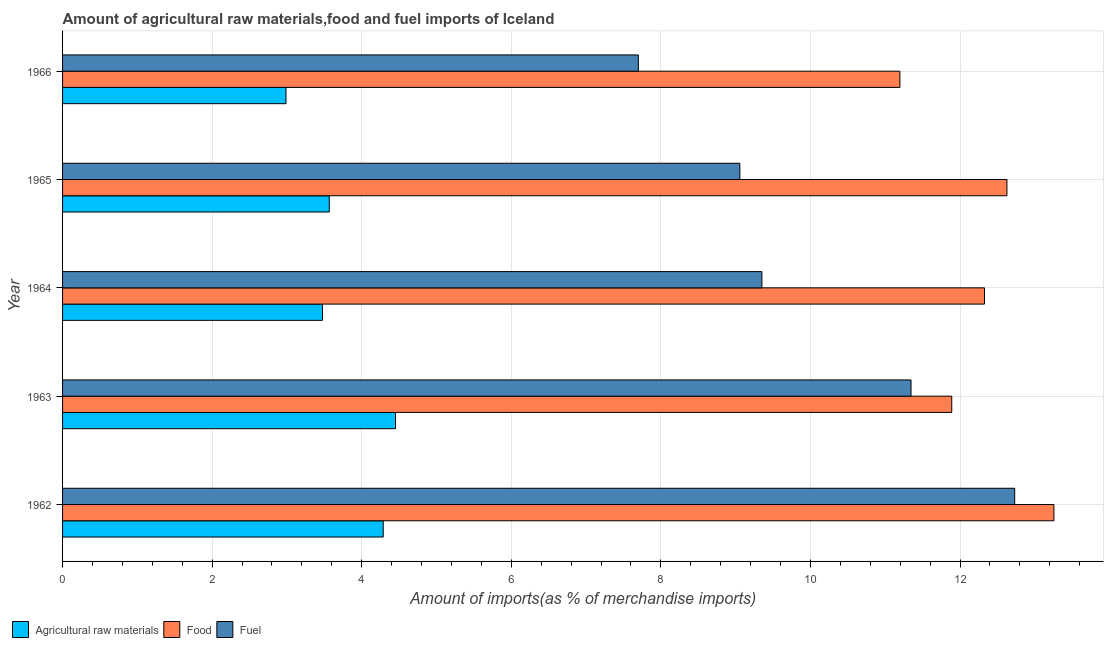How many different coloured bars are there?
Keep it short and to the point. 3. How many groups of bars are there?
Ensure brevity in your answer.  5. Are the number of bars per tick equal to the number of legend labels?
Ensure brevity in your answer.  Yes. Are the number of bars on each tick of the Y-axis equal?
Provide a short and direct response. Yes. How many bars are there on the 5th tick from the top?
Offer a terse response. 3. How many bars are there on the 3rd tick from the bottom?
Offer a terse response. 3. What is the label of the 1st group of bars from the top?
Offer a very short reply. 1966. What is the percentage of raw materials imports in 1962?
Keep it short and to the point. 4.29. Across all years, what is the maximum percentage of raw materials imports?
Your answer should be compact. 4.45. Across all years, what is the minimum percentage of food imports?
Your answer should be very brief. 11.2. In which year was the percentage of fuel imports maximum?
Provide a short and direct response. 1962. In which year was the percentage of fuel imports minimum?
Give a very brief answer. 1966. What is the total percentage of food imports in the graph?
Provide a short and direct response. 61.3. What is the difference between the percentage of food imports in 1963 and that in 1965?
Provide a short and direct response. -0.74. What is the difference between the percentage of food imports in 1964 and the percentage of fuel imports in 1962?
Provide a succinct answer. -0.4. What is the average percentage of raw materials imports per year?
Your answer should be compact. 3.75. In the year 1964, what is the difference between the percentage of food imports and percentage of raw materials imports?
Provide a short and direct response. 8.85. In how many years, is the percentage of raw materials imports greater than 12.8 %?
Provide a succinct answer. 0. What is the ratio of the percentage of raw materials imports in 1965 to that in 1966?
Your answer should be very brief. 1.19. Is the percentage of raw materials imports in 1962 less than that in 1964?
Make the answer very short. No. Is the difference between the percentage of fuel imports in 1962 and 1964 greater than the difference between the percentage of food imports in 1962 and 1964?
Make the answer very short. Yes. What is the difference between the highest and the second highest percentage of raw materials imports?
Offer a very short reply. 0.16. What is the difference between the highest and the lowest percentage of fuel imports?
Ensure brevity in your answer.  5.03. What does the 2nd bar from the top in 1964 represents?
Give a very brief answer. Food. What does the 2nd bar from the bottom in 1962 represents?
Offer a very short reply. Food. Is it the case that in every year, the sum of the percentage of raw materials imports and percentage of food imports is greater than the percentage of fuel imports?
Give a very brief answer. Yes. How many years are there in the graph?
Your answer should be very brief. 5. Does the graph contain any zero values?
Keep it short and to the point. No. Where does the legend appear in the graph?
Make the answer very short. Bottom left. How many legend labels are there?
Your response must be concise. 3. How are the legend labels stacked?
Your answer should be compact. Horizontal. What is the title of the graph?
Offer a terse response. Amount of agricultural raw materials,food and fuel imports of Iceland. What is the label or title of the X-axis?
Keep it short and to the point. Amount of imports(as % of merchandise imports). What is the Amount of imports(as % of merchandise imports) in Agricultural raw materials in 1962?
Offer a terse response. 4.29. What is the Amount of imports(as % of merchandise imports) in Food in 1962?
Ensure brevity in your answer.  13.26. What is the Amount of imports(as % of merchandise imports) in Fuel in 1962?
Your answer should be very brief. 12.73. What is the Amount of imports(as % of merchandise imports) in Agricultural raw materials in 1963?
Your response must be concise. 4.45. What is the Amount of imports(as % of merchandise imports) in Food in 1963?
Keep it short and to the point. 11.89. What is the Amount of imports(as % of merchandise imports) of Fuel in 1963?
Keep it short and to the point. 11.35. What is the Amount of imports(as % of merchandise imports) of Agricultural raw materials in 1964?
Your response must be concise. 3.48. What is the Amount of imports(as % of merchandise imports) of Food in 1964?
Your answer should be very brief. 12.33. What is the Amount of imports(as % of merchandise imports) in Fuel in 1964?
Offer a very short reply. 9.35. What is the Amount of imports(as % of merchandise imports) in Agricultural raw materials in 1965?
Make the answer very short. 3.57. What is the Amount of imports(as % of merchandise imports) of Food in 1965?
Your answer should be very brief. 12.63. What is the Amount of imports(as % of merchandise imports) of Fuel in 1965?
Your answer should be compact. 9.06. What is the Amount of imports(as % of merchandise imports) of Agricultural raw materials in 1966?
Make the answer very short. 2.99. What is the Amount of imports(as % of merchandise imports) of Food in 1966?
Provide a succinct answer. 11.2. What is the Amount of imports(as % of merchandise imports) in Fuel in 1966?
Give a very brief answer. 7.7. Across all years, what is the maximum Amount of imports(as % of merchandise imports) of Agricultural raw materials?
Make the answer very short. 4.45. Across all years, what is the maximum Amount of imports(as % of merchandise imports) in Food?
Provide a short and direct response. 13.26. Across all years, what is the maximum Amount of imports(as % of merchandise imports) in Fuel?
Keep it short and to the point. 12.73. Across all years, what is the minimum Amount of imports(as % of merchandise imports) in Agricultural raw materials?
Your answer should be compact. 2.99. Across all years, what is the minimum Amount of imports(as % of merchandise imports) of Food?
Give a very brief answer. 11.2. Across all years, what is the minimum Amount of imports(as % of merchandise imports) of Fuel?
Keep it short and to the point. 7.7. What is the total Amount of imports(as % of merchandise imports) in Agricultural raw materials in the graph?
Make the answer very short. 18.77. What is the total Amount of imports(as % of merchandise imports) in Food in the graph?
Your answer should be very brief. 61.3. What is the total Amount of imports(as % of merchandise imports) in Fuel in the graph?
Ensure brevity in your answer.  50.18. What is the difference between the Amount of imports(as % of merchandise imports) of Agricultural raw materials in 1962 and that in 1963?
Offer a terse response. -0.16. What is the difference between the Amount of imports(as % of merchandise imports) in Food in 1962 and that in 1963?
Your answer should be compact. 1.37. What is the difference between the Amount of imports(as % of merchandise imports) in Fuel in 1962 and that in 1963?
Make the answer very short. 1.39. What is the difference between the Amount of imports(as % of merchandise imports) in Agricultural raw materials in 1962 and that in 1964?
Keep it short and to the point. 0.81. What is the difference between the Amount of imports(as % of merchandise imports) in Food in 1962 and that in 1964?
Provide a short and direct response. 0.93. What is the difference between the Amount of imports(as % of merchandise imports) of Fuel in 1962 and that in 1964?
Offer a very short reply. 3.38. What is the difference between the Amount of imports(as % of merchandise imports) in Agricultural raw materials in 1962 and that in 1965?
Offer a very short reply. 0.72. What is the difference between the Amount of imports(as % of merchandise imports) of Food in 1962 and that in 1965?
Ensure brevity in your answer.  0.63. What is the difference between the Amount of imports(as % of merchandise imports) of Fuel in 1962 and that in 1965?
Give a very brief answer. 3.67. What is the difference between the Amount of imports(as % of merchandise imports) of Agricultural raw materials in 1962 and that in 1966?
Offer a terse response. 1.3. What is the difference between the Amount of imports(as % of merchandise imports) in Food in 1962 and that in 1966?
Your answer should be compact. 2.06. What is the difference between the Amount of imports(as % of merchandise imports) in Fuel in 1962 and that in 1966?
Make the answer very short. 5.03. What is the difference between the Amount of imports(as % of merchandise imports) in Agricultural raw materials in 1963 and that in 1964?
Offer a terse response. 0.98. What is the difference between the Amount of imports(as % of merchandise imports) of Food in 1963 and that in 1964?
Offer a terse response. -0.44. What is the difference between the Amount of imports(as % of merchandise imports) in Fuel in 1963 and that in 1964?
Your answer should be very brief. 1.99. What is the difference between the Amount of imports(as % of merchandise imports) of Agricultural raw materials in 1963 and that in 1965?
Offer a terse response. 0.89. What is the difference between the Amount of imports(as % of merchandise imports) in Food in 1963 and that in 1965?
Give a very brief answer. -0.74. What is the difference between the Amount of imports(as % of merchandise imports) of Fuel in 1963 and that in 1965?
Your answer should be compact. 2.29. What is the difference between the Amount of imports(as % of merchandise imports) of Agricultural raw materials in 1963 and that in 1966?
Offer a very short reply. 1.46. What is the difference between the Amount of imports(as % of merchandise imports) in Food in 1963 and that in 1966?
Provide a succinct answer. 0.69. What is the difference between the Amount of imports(as % of merchandise imports) in Fuel in 1963 and that in 1966?
Provide a short and direct response. 3.65. What is the difference between the Amount of imports(as % of merchandise imports) in Agricultural raw materials in 1964 and that in 1965?
Make the answer very short. -0.09. What is the difference between the Amount of imports(as % of merchandise imports) of Food in 1964 and that in 1965?
Your answer should be very brief. -0.3. What is the difference between the Amount of imports(as % of merchandise imports) of Fuel in 1964 and that in 1965?
Your answer should be compact. 0.29. What is the difference between the Amount of imports(as % of merchandise imports) in Agricultural raw materials in 1964 and that in 1966?
Give a very brief answer. 0.49. What is the difference between the Amount of imports(as % of merchandise imports) in Food in 1964 and that in 1966?
Keep it short and to the point. 1.13. What is the difference between the Amount of imports(as % of merchandise imports) of Fuel in 1964 and that in 1966?
Your response must be concise. 1.65. What is the difference between the Amount of imports(as % of merchandise imports) of Agricultural raw materials in 1965 and that in 1966?
Your answer should be compact. 0.58. What is the difference between the Amount of imports(as % of merchandise imports) of Food in 1965 and that in 1966?
Make the answer very short. 1.43. What is the difference between the Amount of imports(as % of merchandise imports) in Fuel in 1965 and that in 1966?
Ensure brevity in your answer.  1.36. What is the difference between the Amount of imports(as % of merchandise imports) of Agricultural raw materials in 1962 and the Amount of imports(as % of merchandise imports) of Food in 1963?
Make the answer very short. -7.6. What is the difference between the Amount of imports(as % of merchandise imports) in Agricultural raw materials in 1962 and the Amount of imports(as % of merchandise imports) in Fuel in 1963?
Provide a succinct answer. -7.06. What is the difference between the Amount of imports(as % of merchandise imports) in Food in 1962 and the Amount of imports(as % of merchandise imports) in Fuel in 1963?
Ensure brevity in your answer.  1.91. What is the difference between the Amount of imports(as % of merchandise imports) of Agricultural raw materials in 1962 and the Amount of imports(as % of merchandise imports) of Food in 1964?
Offer a very short reply. -8.04. What is the difference between the Amount of imports(as % of merchandise imports) of Agricultural raw materials in 1962 and the Amount of imports(as % of merchandise imports) of Fuel in 1964?
Give a very brief answer. -5.06. What is the difference between the Amount of imports(as % of merchandise imports) of Food in 1962 and the Amount of imports(as % of merchandise imports) of Fuel in 1964?
Offer a very short reply. 3.9. What is the difference between the Amount of imports(as % of merchandise imports) of Agricultural raw materials in 1962 and the Amount of imports(as % of merchandise imports) of Food in 1965?
Your answer should be very brief. -8.34. What is the difference between the Amount of imports(as % of merchandise imports) in Agricultural raw materials in 1962 and the Amount of imports(as % of merchandise imports) in Fuel in 1965?
Your response must be concise. -4.77. What is the difference between the Amount of imports(as % of merchandise imports) of Food in 1962 and the Amount of imports(as % of merchandise imports) of Fuel in 1965?
Provide a succinct answer. 4.2. What is the difference between the Amount of imports(as % of merchandise imports) of Agricultural raw materials in 1962 and the Amount of imports(as % of merchandise imports) of Food in 1966?
Keep it short and to the point. -6.91. What is the difference between the Amount of imports(as % of merchandise imports) of Agricultural raw materials in 1962 and the Amount of imports(as % of merchandise imports) of Fuel in 1966?
Make the answer very short. -3.41. What is the difference between the Amount of imports(as % of merchandise imports) in Food in 1962 and the Amount of imports(as % of merchandise imports) in Fuel in 1966?
Offer a very short reply. 5.56. What is the difference between the Amount of imports(as % of merchandise imports) of Agricultural raw materials in 1963 and the Amount of imports(as % of merchandise imports) of Food in 1964?
Give a very brief answer. -7.88. What is the difference between the Amount of imports(as % of merchandise imports) of Agricultural raw materials in 1963 and the Amount of imports(as % of merchandise imports) of Fuel in 1964?
Your answer should be very brief. -4.9. What is the difference between the Amount of imports(as % of merchandise imports) of Food in 1963 and the Amount of imports(as % of merchandise imports) of Fuel in 1964?
Your answer should be very brief. 2.54. What is the difference between the Amount of imports(as % of merchandise imports) in Agricultural raw materials in 1963 and the Amount of imports(as % of merchandise imports) in Food in 1965?
Give a very brief answer. -8.18. What is the difference between the Amount of imports(as % of merchandise imports) of Agricultural raw materials in 1963 and the Amount of imports(as % of merchandise imports) of Fuel in 1965?
Your response must be concise. -4.6. What is the difference between the Amount of imports(as % of merchandise imports) in Food in 1963 and the Amount of imports(as % of merchandise imports) in Fuel in 1965?
Provide a short and direct response. 2.83. What is the difference between the Amount of imports(as % of merchandise imports) of Agricultural raw materials in 1963 and the Amount of imports(as % of merchandise imports) of Food in 1966?
Provide a short and direct response. -6.74. What is the difference between the Amount of imports(as % of merchandise imports) in Agricultural raw materials in 1963 and the Amount of imports(as % of merchandise imports) in Fuel in 1966?
Provide a succinct answer. -3.25. What is the difference between the Amount of imports(as % of merchandise imports) of Food in 1963 and the Amount of imports(as % of merchandise imports) of Fuel in 1966?
Keep it short and to the point. 4.19. What is the difference between the Amount of imports(as % of merchandise imports) of Agricultural raw materials in 1964 and the Amount of imports(as % of merchandise imports) of Food in 1965?
Ensure brevity in your answer.  -9.15. What is the difference between the Amount of imports(as % of merchandise imports) of Agricultural raw materials in 1964 and the Amount of imports(as % of merchandise imports) of Fuel in 1965?
Give a very brief answer. -5.58. What is the difference between the Amount of imports(as % of merchandise imports) of Food in 1964 and the Amount of imports(as % of merchandise imports) of Fuel in 1965?
Give a very brief answer. 3.27. What is the difference between the Amount of imports(as % of merchandise imports) of Agricultural raw materials in 1964 and the Amount of imports(as % of merchandise imports) of Food in 1966?
Provide a succinct answer. -7.72. What is the difference between the Amount of imports(as % of merchandise imports) in Agricultural raw materials in 1964 and the Amount of imports(as % of merchandise imports) in Fuel in 1966?
Your answer should be very brief. -4.22. What is the difference between the Amount of imports(as % of merchandise imports) in Food in 1964 and the Amount of imports(as % of merchandise imports) in Fuel in 1966?
Offer a terse response. 4.63. What is the difference between the Amount of imports(as % of merchandise imports) of Agricultural raw materials in 1965 and the Amount of imports(as % of merchandise imports) of Food in 1966?
Offer a very short reply. -7.63. What is the difference between the Amount of imports(as % of merchandise imports) in Agricultural raw materials in 1965 and the Amount of imports(as % of merchandise imports) in Fuel in 1966?
Your answer should be very brief. -4.13. What is the difference between the Amount of imports(as % of merchandise imports) of Food in 1965 and the Amount of imports(as % of merchandise imports) of Fuel in 1966?
Keep it short and to the point. 4.93. What is the average Amount of imports(as % of merchandise imports) of Agricultural raw materials per year?
Offer a very short reply. 3.75. What is the average Amount of imports(as % of merchandise imports) in Food per year?
Ensure brevity in your answer.  12.26. What is the average Amount of imports(as % of merchandise imports) in Fuel per year?
Ensure brevity in your answer.  10.04. In the year 1962, what is the difference between the Amount of imports(as % of merchandise imports) in Agricultural raw materials and Amount of imports(as % of merchandise imports) in Food?
Your answer should be compact. -8.97. In the year 1962, what is the difference between the Amount of imports(as % of merchandise imports) of Agricultural raw materials and Amount of imports(as % of merchandise imports) of Fuel?
Your answer should be very brief. -8.44. In the year 1962, what is the difference between the Amount of imports(as % of merchandise imports) in Food and Amount of imports(as % of merchandise imports) in Fuel?
Provide a succinct answer. 0.52. In the year 1963, what is the difference between the Amount of imports(as % of merchandise imports) in Agricultural raw materials and Amount of imports(as % of merchandise imports) in Food?
Keep it short and to the point. -7.44. In the year 1963, what is the difference between the Amount of imports(as % of merchandise imports) in Agricultural raw materials and Amount of imports(as % of merchandise imports) in Fuel?
Give a very brief answer. -6.89. In the year 1963, what is the difference between the Amount of imports(as % of merchandise imports) of Food and Amount of imports(as % of merchandise imports) of Fuel?
Make the answer very short. 0.54. In the year 1964, what is the difference between the Amount of imports(as % of merchandise imports) in Agricultural raw materials and Amount of imports(as % of merchandise imports) in Food?
Provide a succinct answer. -8.85. In the year 1964, what is the difference between the Amount of imports(as % of merchandise imports) of Agricultural raw materials and Amount of imports(as % of merchandise imports) of Fuel?
Ensure brevity in your answer.  -5.88. In the year 1964, what is the difference between the Amount of imports(as % of merchandise imports) of Food and Amount of imports(as % of merchandise imports) of Fuel?
Keep it short and to the point. 2.98. In the year 1965, what is the difference between the Amount of imports(as % of merchandise imports) of Agricultural raw materials and Amount of imports(as % of merchandise imports) of Food?
Offer a terse response. -9.06. In the year 1965, what is the difference between the Amount of imports(as % of merchandise imports) of Agricultural raw materials and Amount of imports(as % of merchandise imports) of Fuel?
Provide a short and direct response. -5.49. In the year 1965, what is the difference between the Amount of imports(as % of merchandise imports) in Food and Amount of imports(as % of merchandise imports) in Fuel?
Keep it short and to the point. 3.57. In the year 1966, what is the difference between the Amount of imports(as % of merchandise imports) of Agricultural raw materials and Amount of imports(as % of merchandise imports) of Food?
Provide a succinct answer. -8.21. In the year 1966, what is the difference between the Amount of imports(as % of merchandise imports) of Agricultural raw materials and Amount of imports(as % of merchandise imports) of Fuel?
Ensure brevity in your answer.  -4.71. In the year 1966, what is the difference between the Amount of imports(as % of merchandise imports) in Food and Amount of imports(as % of merchandise imports) in Fuel?
Give a very brief answer. 3.5. What is the ratio of the Amount of imports(as % of merchandise imports) of Agricultural raw materials in 1962 to that in 1963?
Your response must be concise. 0.96. What is the ratio of the Amount of imports(as % of merchandise imports) in Food in 1962 to that in 1963?
Give a very brief answer. 1.11. What is the ratio of the Amount of imports(as % of merchandise imports) of Fuel in 1962 to that in 1963?
Make the answer very short. 1.12. What is the ratio of the Amount of imports(as % of merchandise imports) of Agricultural raw materials in 1962 to that in 1964?
Offer a very short reply. 1.23. What is the ratio of the Amount of imports(as % of merchandise imports) in Food in 1962 to that in 1964?
Your response must be concise. 1.08. What is the ratio of the Amount of imports(as % of merchandise imports) of Fuel in 1962 to that in 1964?
Your answer should be compact. 1.36. What is the ratio of the Amount of imports(as % of merchandise imports) in Agricultural raw materials in 1962 to that in 1965?
Offer a very short reply. 1.2. What is the ratio of the Amount of imports(as % of merchandise imports) of Food in 1962 to that in 1965?
Offer a terse response. 1.05. What is the ratio of the Amount of imports(as % of merchandise imports) in Fuel in 1962 to that in 1965?
Ensure brevity in your answer.  1.41. What is the ratio of the Amount of imports(as % of merchandise imports) of Agricultural raw materials in 1962 to that in 1966?
Make the answer very short. 1.44. What is the ratio of the Amount of imports(as % of merchandise imports) of Food in 1962 to that in 1966?
Provide a succinct answer. 1.18. What is the ratio of the Amount of imports(as % of merchandise imports) of Fuel in 1962 to that in 1966?
Offer a very short reply. 1.65. What is the ratio of the Amount of imports(as % of merchandise imports) of Agricultural raw materials in 1963 to that in 1964?
Provide a succinct answer. 1.28. What is the ratio of the Amount of imports(as % of merchandise imports) of Food in 1963 to that in 1964?
Keep it short and to the point. 0.96. What is the ratio of the Amount of imports(as % of merchandise imports) in Fuel in 1963 to that in 1964?
Offer a very short reply. 1.21. What is the ratio of the Amount of imports(as % of merchandise imports) in Agricultural raw materials in 1963 to that in 1965?
Ensure brevity in your answer.  1.25. What is the ratio of the Amount of imports(as % of merchandise imports) in Food in 1963 to that in 1965?
Offer a terse response. 0.94. What is the ratio of the Amount of imports(as % of merchandise imports) of Fuel in 1963 to that in 1965?
Your answer should be very brief. 1.25. What is the ratio of the Amount of imports(as % of merchandise imports) in Agricultural raw materials in 1963 to that in 1966?
Keep it short and to the point. 1.49. What is the ratio of the Amount of imports(as % of merchandise imports) of Food in 1963 to that in 1966?
Offer a terse response. 1.06. What is the ratio of the Amount of imports(as % of merchandise imports) in Fuel in 1963 to that in 1966?
Give a very brief answer. 1.47. What is the ratio of the Amount of imports(as % of merchandise imports) of Agricultural raw materials in 1964 to that in 1965?
Your response must be concise. 0.97. What is the ratio of the Amount of imports(as % of merchandise imports) in Food in 1964 to that in 1965?
Your answer should be compact. 0.98. What is the ratio of the Amount of imports(as % of merchandise imports) of Fuel in 1964 to that in 1965?
Your response must be concise. 1.03. What is the ratio of the Amount of imports(as % of merchandise imports) of Agricultural raw materials in 1964 to that in 1966?
Your answer should be compact. 1.16. What is the ratio of the Amount of imports(as % of merchandise imports) in Food in 1964 to that in 1966?
Your answer should be very brief. 1.1. What is the ratio of the Amount of imports(as % of merchandise imports) in Fuel in 1964 to that in 1966?
Your response must be concise. 1.21. What is the ratio of the Amount of imports(as % of merchandise imports) of Agricultural raw materials in 1965 to that in 1966?
Offer a very short reply. 1.19. What is the ratio of the Amount of imports(as % of merchandise imports) in Food in 1965 to that in 1966?
Keep it short and to the point. 1.13. What is the ratio of the Amount of imports(as % of merchandise imports) in Fuel in 1965 to that in 1966?
Give a very brief answer. 1.18. What is the difference between the highest and the second highest Amount of imports(as % of merchandise imports) in Agricultural raw materials?
Provide a short and direct response. 0.16. What is the difference between the highest and the second highest Amount of imports(as % of merchandise imports) in Food?
Ensure brevity in your answer.  0.63. What is the difference between the highest and the second highest Amount of imports(as % of merchandise imports) of Fuel?
Provide a short and direct response. 1.39. What is the difference between the highest and the lowest Amount of imports(as % of merchandise imports) of Agricultural raw materials?
Keep it short and to the point. 1.46. What is the difference between the highest and the lowest Amount of imports(as % of merchandise imports) in Food?
Your response must be concise. 2.06. What is the difference between the highest and the lowest Amount of imports(as % of merchandise imports) of Fuel?
Offer a terse response. 5.03. 